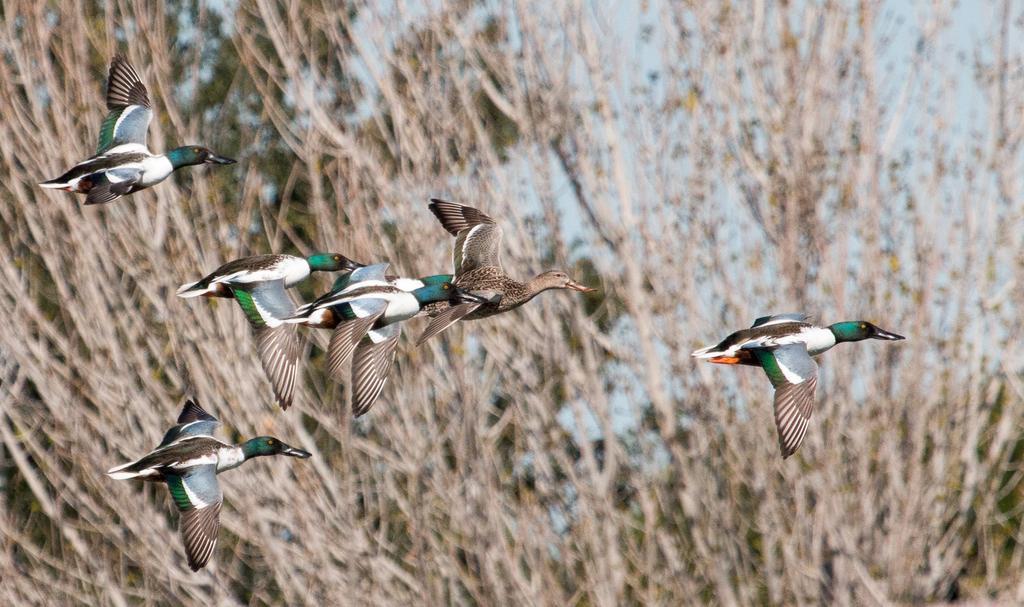Describe this image in one or two sentences. This image is clicked outside. There are so many birds in the middle. There is something like plants in the back side. 